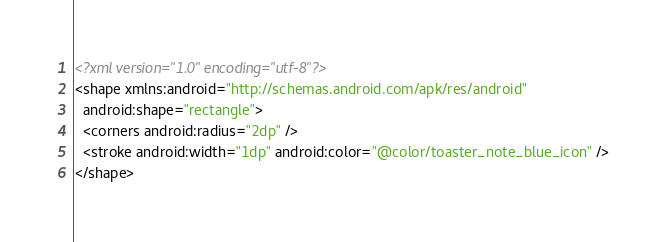Convert code to text. <code><loc_0><loc_0><loc_500><loc_500><_XML_><?xml version="1.0" encoding="utf-8"?>
<shape xmlns:android="http://schemas.android.com/apk/res/android"
  android:shape="rectangle">
  <corners android:radius="2dp" />
  <stroke android:width="1dp" android:color="@color/toaster_note_blue_icon" />
</shape></code> 